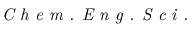Convert formula to latex. <formula><loc_0><loc_0><loc_500><loc_500>C h e m . E n g . S c i .</formula> 